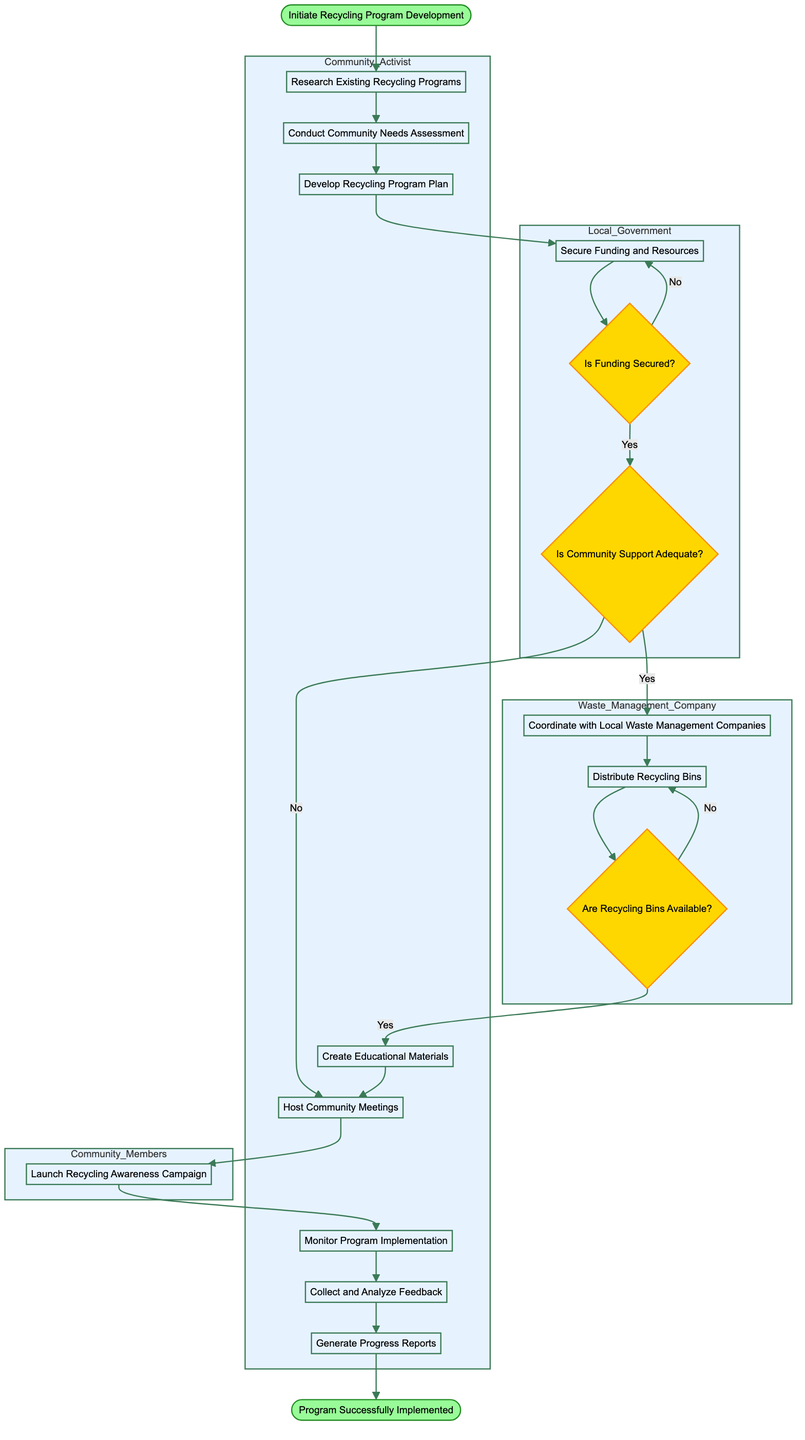What is the initial event in this diagram? The diagram starts with "Initiate Recycling Program Development," which is the first step indicated as the starting event.
Answer: Initiate Recycling Program Development How many activities are listed in the diagram? There are 12 activities enumerated in the diagram, as identified within the respective swimlane for the Community Activist and the local involvement areas.
Answer: 12 What decision follows the "Secure Funding and Resources" activity? After securing funding, the next decision is "Is Funding Secured?" which determines the subsequent flow based on funding status.
Answer: Is Funding Secured? What is the path from community assessment to education materials? The path goes: Conduct Community Needs Assessment → Develop Recycling Program Plan → Create Educational Materials, representing sequential dependencies.
Answer: Conduct Community Needs Assessment → Develop Recycling Program Plan → Create Educational Materials How many swimlanes are present in the diagram? There are 4 swimlanes: Community Activist, Local Government, Waste Management Company, and Community Members, which structure the activities performed by different groups.
Answer: 4 What happens if the funding is not secured? If funding is not secured, the flow returns to "Secure Funding and Resources," indicating a need to revisit this step until funding is acquired.
Answer: Returns to Secure Funding and Resources What is the last action before the program is successfully implemented? The last action before reaching the end event is "Generate Progress Reports," which indicates evaluation and documentation of the program's outcomes.
Answer: Generate Progress Reports In which activity do community members engage? Community members engage in the activity "Launch Recycling Awareness Campaign," which encourages participation in the recycling efforts.
Answer: Launch Recycling Awareness Campaign What must be checked after distributing recycling bins? After distributing recycling bins, the decision "Are Recycling Bins Available?" must be checked to ascertain if sufficient resources are in place for the program’s functionality.
Answer: Are Recycling Bins Available? 